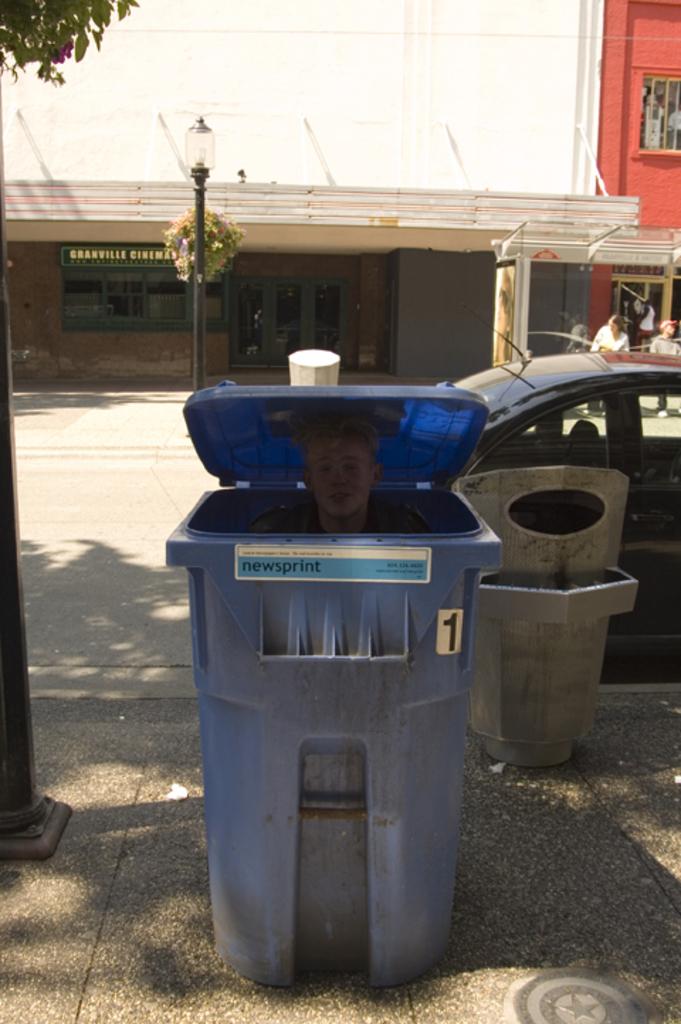What number is on the bin?
Your answer should be very brief. 1. What is written in the blue?
Ensure brevity in your answer.  Newsprint. 